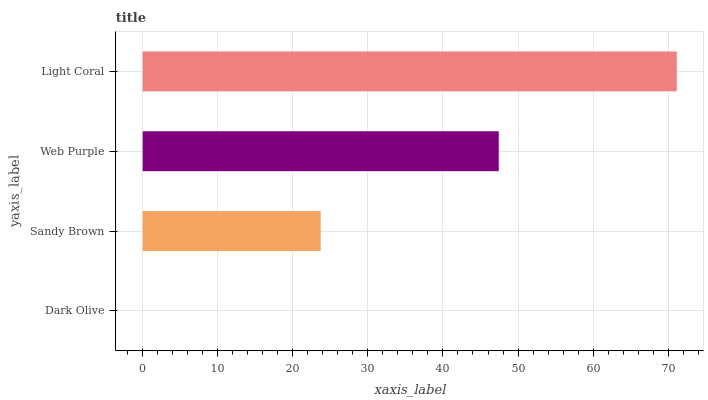Is Dark Olive the minimum?
Answer yes or no. Yes. Is Light Coral the maximum?
Answer yes or no. Yes. Is Sandy Brown the minimum?
Answer yes or no. No. Is Sandy Brown the maximum?
Answer yes or no. No. Is Sandy Brown greater than Dark Olive?
Answer yes or no. Yes. Is Dark Olive less than Sandy Brown?
Answer yes or no. Yes. Is Dark Olive greater than Sandy Brown?
Answer yes or no. No. Is Sandy Brown less than Dark Olive?
Answer yes or no. No. Is Web Purple the high median?
Answer yes or no. Yes. Is Sandy Brown the low median?
Answer yes or no. Yes. Is Sandy Brown the high median?
Answer yes or no. No. Is Light Coral the low median?
Answer yes or no. No. 